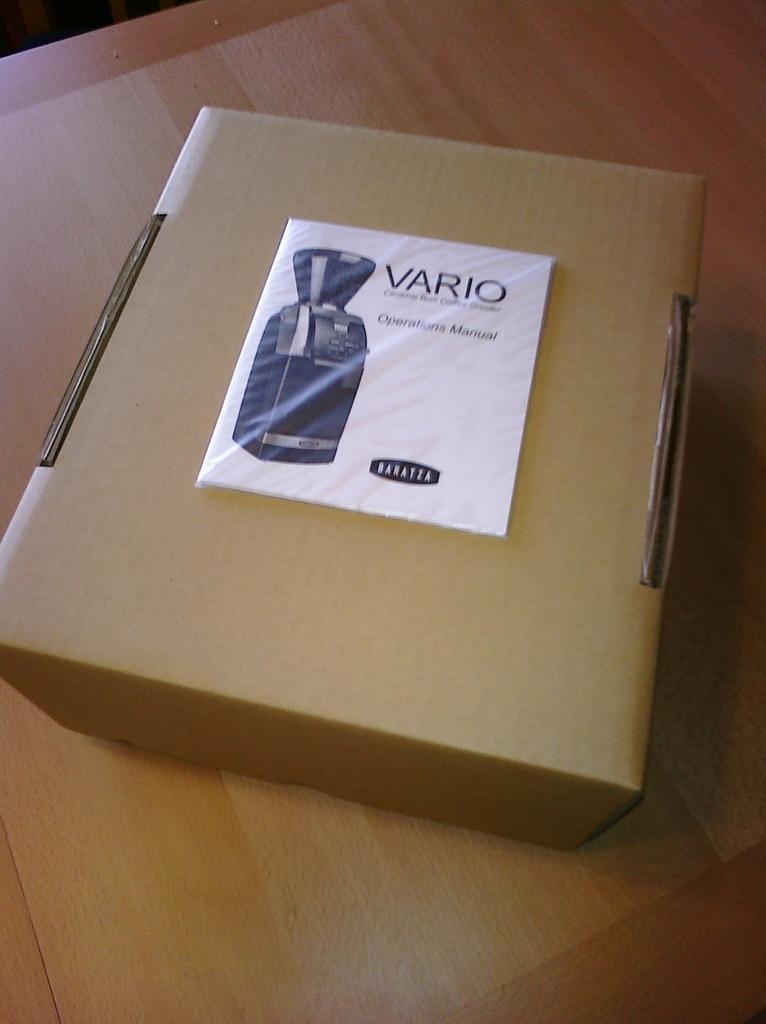Could you give a brief overview of what you see in this image? In this image we can see a cardboard box which is placed on a table. 